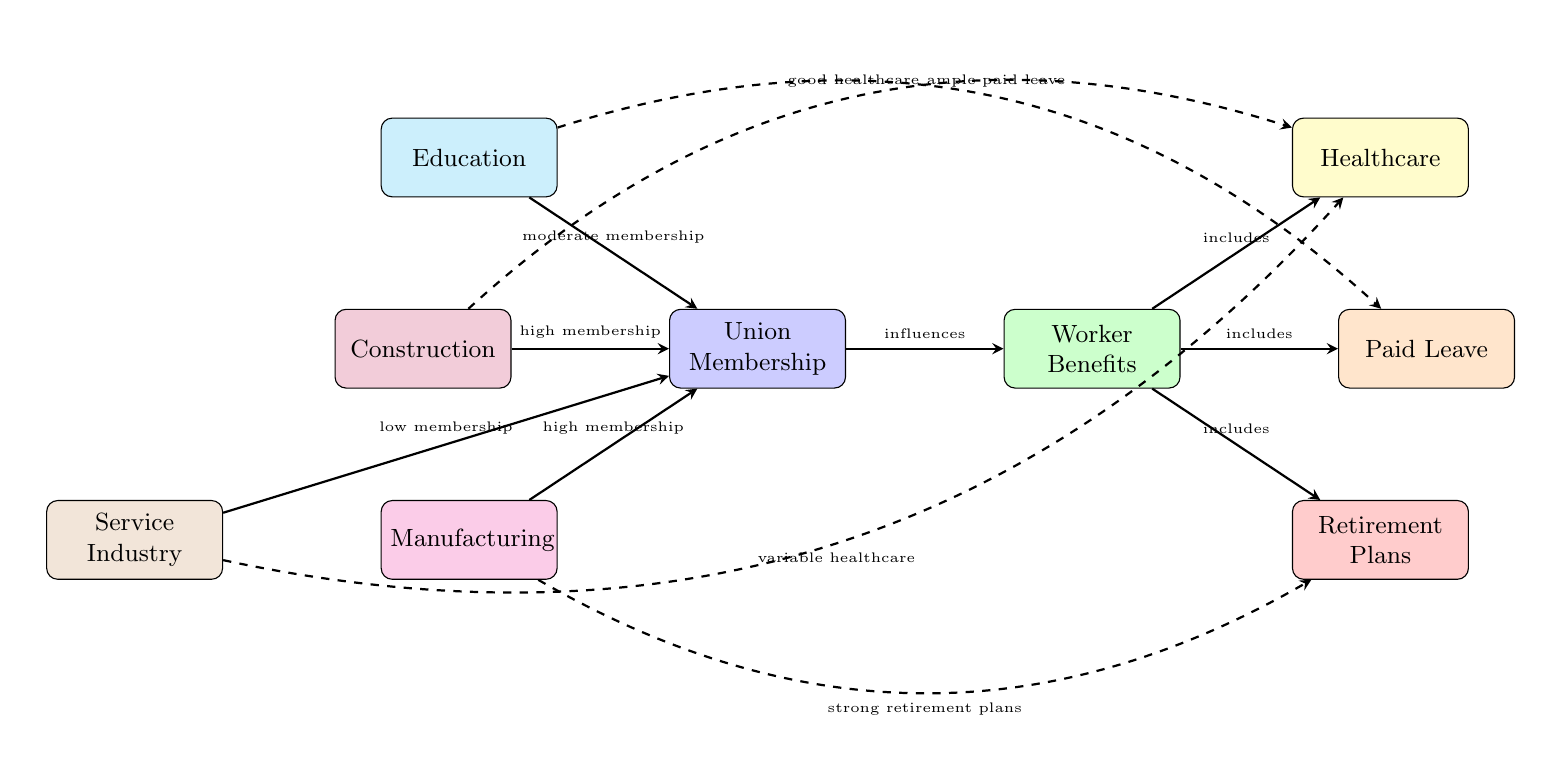What is the membership level in the construction industry? The diagram indicates that the construction industry has "high membership" in union membership. This information is directly labeled on the arrow pointing from the construction node to the union membership node.
Answer: high membership Which worker benefit is associated with education? The diagram shows that the education industry has "ample paid leave" which is indicated by the dashed arrow connecting the education node to the paid leave node.
Answer: ample paid leave How many worker benefits are listed in the diagram? The diagram displays three worker benefits: healthcare, paid leave, and retirement plans. Counting these nodes provides the answer of three.
Answer: three What type of membership does the service industry have? The diagram states that the service industry has "low membership," which is specified by the label on the arrow pointing from the service industry node to the union membership node.
Answer: low membership What type of healthcare benefit is displayed for the service industry? The dashed arrow indicates "variable healthcare" related to the healthcare node coming from the service industry node. This means the service industry has inconsistent healthcare benefits.
Answer: variable healthcare Which industry is represented as having strong retirement plans? According to the diagram, manufacturing is indicated to have "strong retirement plans," which is reflected in the dashed arrow from the manufacturing node to the retirement plans node.
Answer: manufacturing How does union membership influence worker benefits? The diagram illustrates a direct influence where the arrow from the union membership node points to the worker benefits node, labeled "influences." This clearly establishes that union membership has a role in determining the level of worker benefits.
Answer: influences What are the four industries included in the diagram? The diagram includes construction, education, manufacturing, and service industry as its four main nodes representing different industries, which can be identified by counting the distinct nodes labeled on the left side.
Answer: construction, education, manufacturing, service industry What is the direct relationship between worker benefits and healthcare? The diagram specifies that worker benefits "includes" healthcare, as indicated by the arrow going from the worker benefits node to the healthcare node. This suggests that healthcare is a component of the broader category of worker benefits.
Answer: includes 